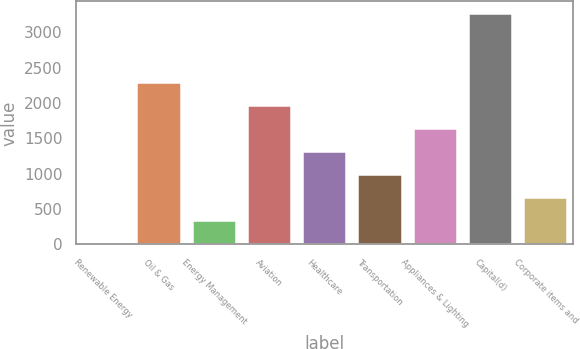Convert chart. <chart><loc_0><loc_0><loc_500><loc_500><bar_chart><fcel>Renewable Energy<fcel>Oil & Gas<fcel>Energy Management<fcel>Aviation<fcel>Healthcare<fcel>Transportation<fcel>Appliances & Lighting<fcel>Capital(d)<fcel>Corporate items and<nl><fcel>23<fcel>2298.7<fcel>348.1<fcel>1973.6<fcel>1323.4<fcel>998.3<fcel>1648.5<fcel>3274<fcel>673.2<nl></chart> 